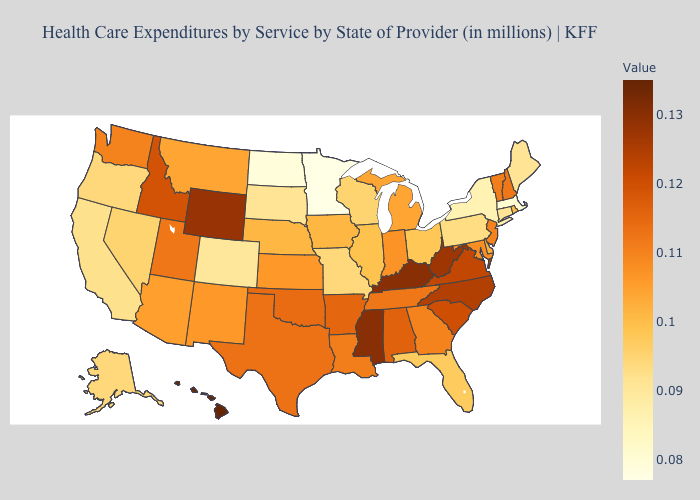Does Hawaii have the highest value in the USA?
Write a very short answer. Yes. Which states have the lowest value in the USA?
Keep it brief. Minnesota. Does Minnesota have the lowest value in the MidWest?
Short answer required. Yes. Which states hav the highest value in the West?
Give a very brief answer. Hawaii. Among the states that border Maryland , does West Virginia have the highest value?
Keep it brief. Yes. Is the legend a continuous bar?
Quick response, please. Yes. Does Massachusetts have the lowest value in the Northeast?
Give a very brief answer. Yes. 